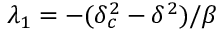<formula> <loc_0><loc_0><loc_500><loc_500>\lambda _ { 1 } = - ( \delta _ { c } ^ { 2 } - \delta ^ { 2 } ) / \beta</formula> 